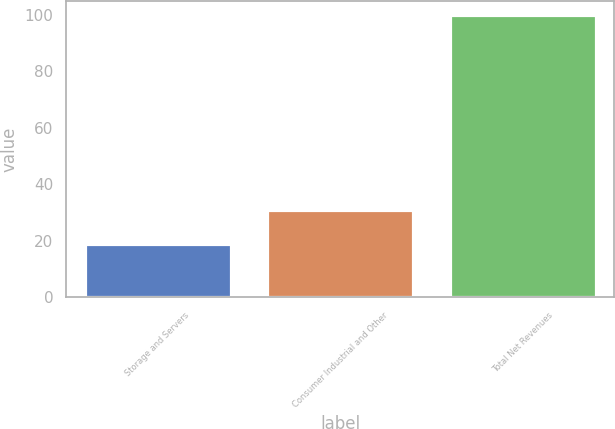Convert chart. <chart><loc_0><loc_0><loc_500><loc_500><bar_chart><fcel>Storage and Servers<fcel>Consumer Industrial and Other<fcel>Total Net Revenues<nl><fcel>19<fcel>31<fcel>100<nl></chart> 